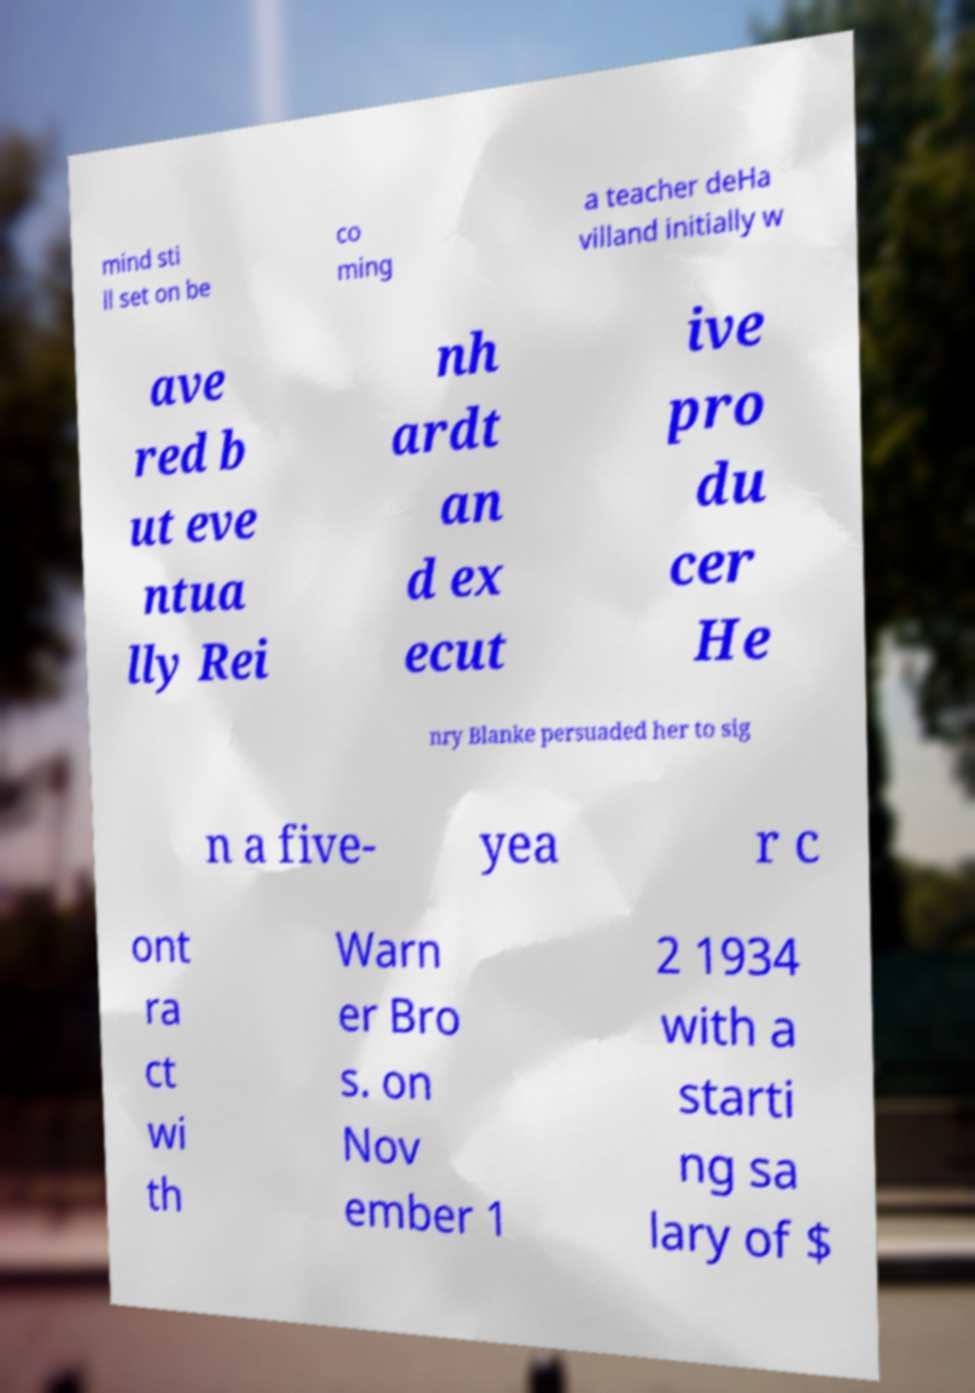For documentation purposes, I need the text within this image transcribed. Could you provide that? mind sti ll set on be co ming a teacher deHa villand initially w ave red b ut eve ntua lly Rei nh ardt an d ex ecut ive pro du cer He nry Blanke persuaded her to sig n a five- yea r c ont ra ct wi th Warn er Bro s. on Nov ember 1 2 1934 with a starti ng sa lary of $ 